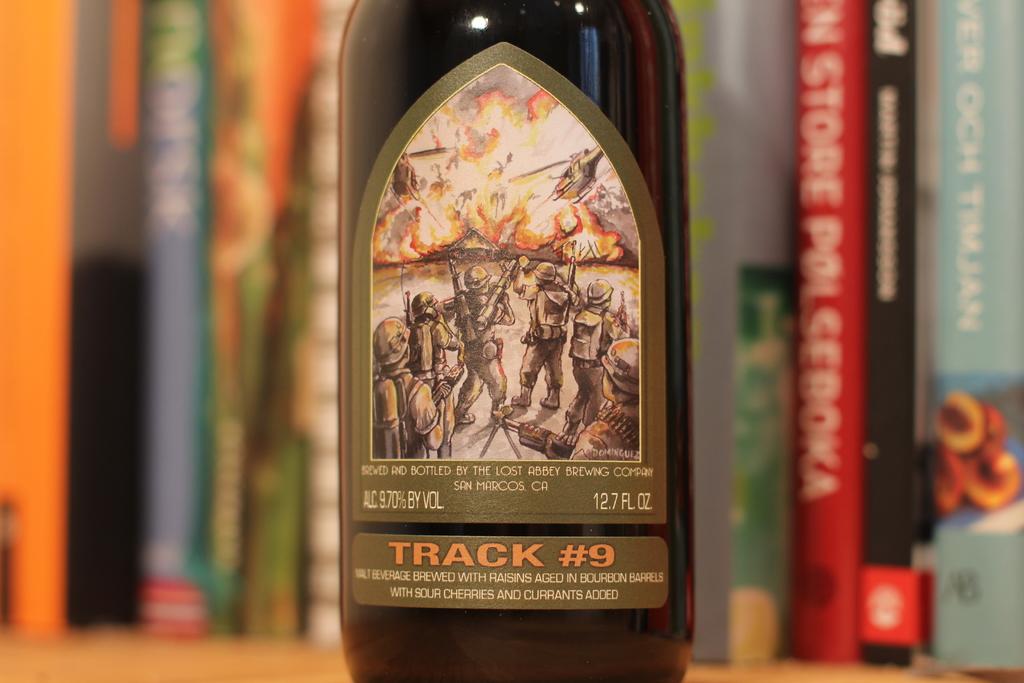What is the track number?
Provide a short and direct response. 9. How many oz. does this bottle have?
Ensure brevity in your answer.  12.7. 